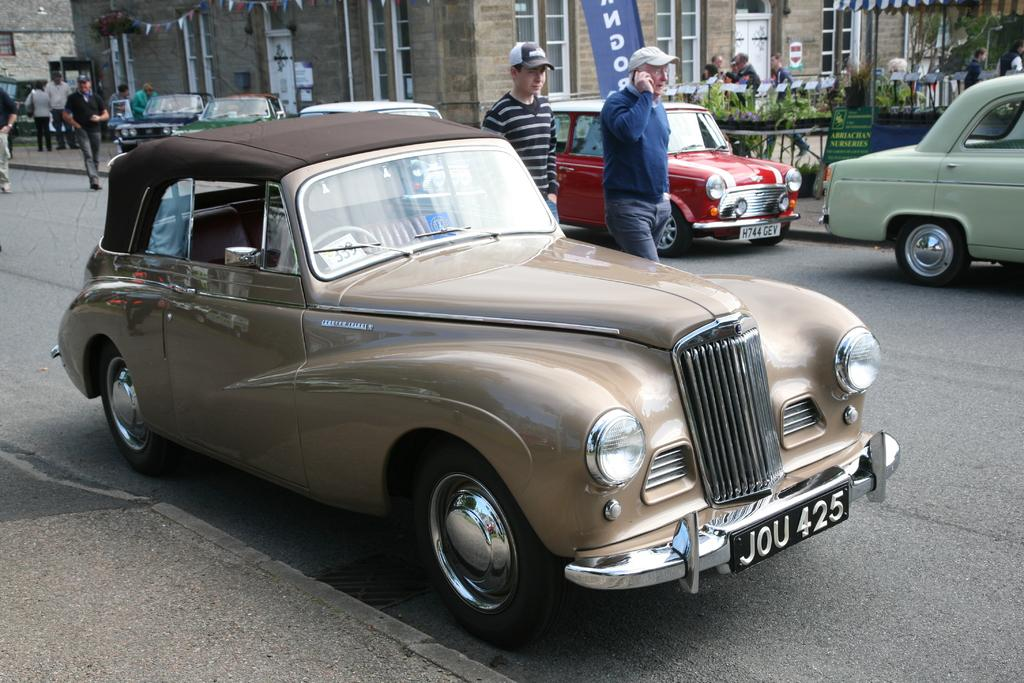What type of vehicles can be seen in the image? There are cars in the image. Who or what else is present in the image? There are people in the image. What can be seen in the distance in the image? There are buildings in the background of the image. What is located on the right side of the image? There is a tent on the right side of the image. What objects are present in the image that might be used for displaying information or advertisements? There are boards in the image. What type of natural elements can be seen in the image? There are plants in the image. Can you see a fingerprint on the car in the image? There is no mention of a fingerprint or any indication that one is present in the image. What type of mint is growing near the tent in the image? There is no mention of mint or any plants in the image that could be identified as mint. 